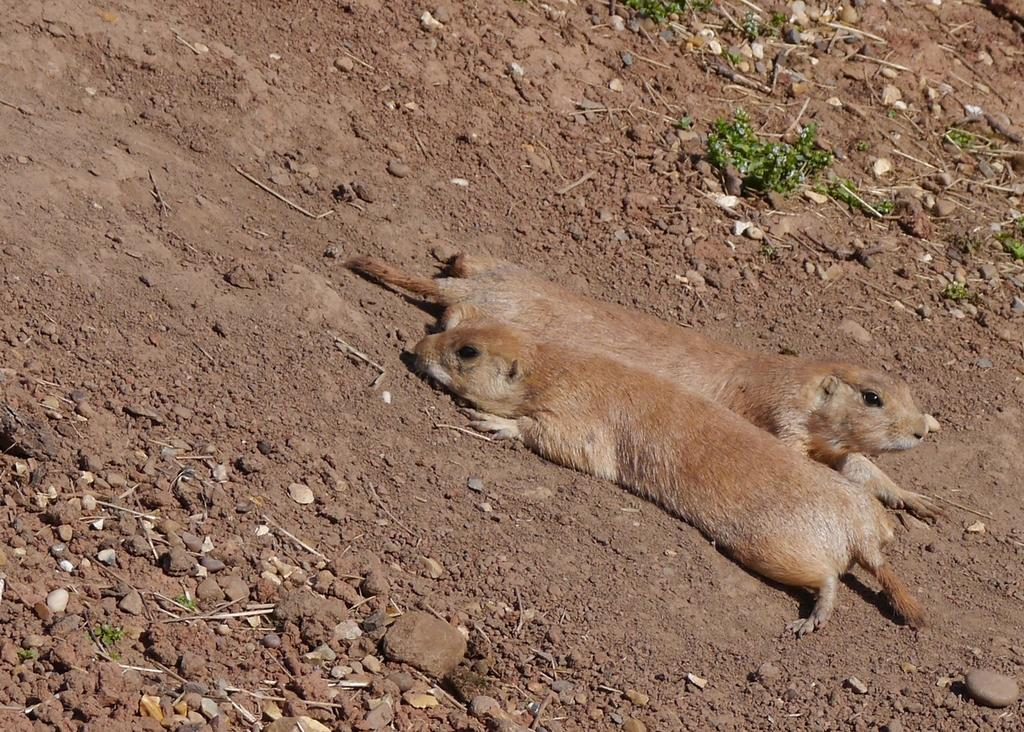How many animals are present in the image? There are two animals in the image. What is the location of the animals in the image? The animals are on the land in the image. What type of vessel is being used by the animals in the image? There is no vessel present in the image; the animals are on the land. What type of mint plant can be seen growing near the animals in the image? There is no mint plant present in the image. 